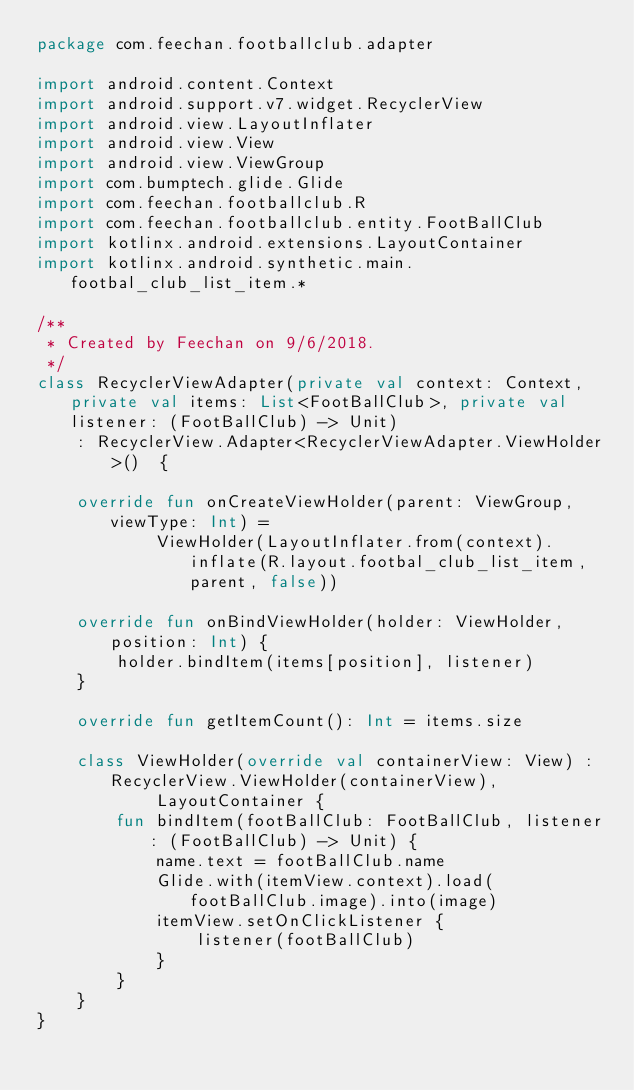Convert code to text. <code><loc_0><loc_0><loc_500><loc_500><_Kotlin_>package com.feechan.footballclub.adapter

import android.content.Context
import android.support.v7.widget.RecyclerView
import android.view.LayoutInflater
import android.view.View
import android.view.ViewGroup
import com.bumptech.glide.Glide
import com.feechan.footballclub.R
import com.feechan.footballclub.entity.FootBallClub
import kotlinx.android.extensions.LayoutContainer
import kotlinx.android.synthetic.main.footbal_club_list_item.*

/**
 * Created by Feechan on 9/6/2018.
 */
class RecyclerViewAdapter(private val context: Context, private val items: List<FootBallClub>, private val listener: (FootBallClub) -> Unit)
    : RecyclerView.Adapter<RecyclerViewAdapter.ViewHolder>()  {

    override fun onCreateViewHolder(parent: ViewGroup, viewType: Int) =
            ViewHolder(LayoutInflater.from(context).inflate(R.layout.footbal_club_list_item, parent, false))

    override fun onBindViewHolder(holder: ViewHolder, position: Int) {
        holder.bindItem(items[position], listener)
    }

    override fun getItemCount(): Int = items.size

    class ViewHolder(override val containerView: View) : RecyclerView.ViewHolder(containerView),
            LayoutContainer {
        fun bindItem(footBallClub: FootBallClub, listener: (FootBallClub) -> Unit) {
            name.text = footBallClub.name
            Glide.with(itemView.context).load(footBallClub.image).into(image)
            itemView.setOnClickListener {
                listener(footBallClub)
            }
        }
    }
}</code> 